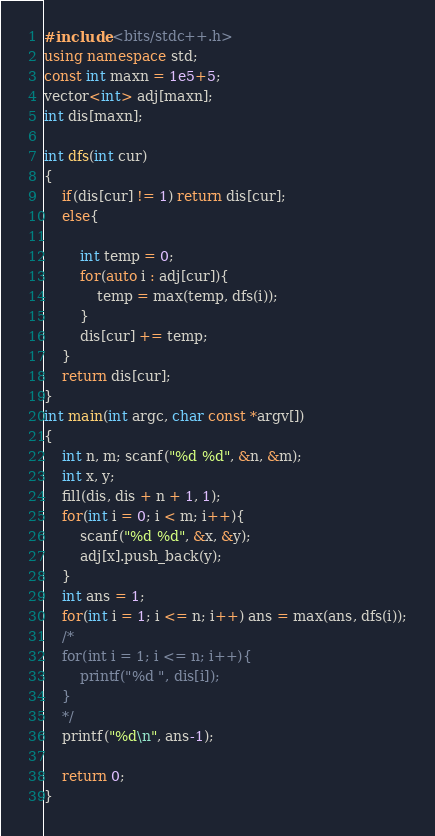<code> <loc_0><loc_0><loc_500><loc_500><_C++_>#include <bits/stdc++.h>
using namespace std;
const int maxn = 1e5+5;
vector<int> adj[maxn];
int dis[maxn];

int dfs(int cur)
{
	if(dis[cur] != 1) return dis[cur];
	else{

		int temp = 0;
		for(auto i : adj[cur]){
			temp = max(temp, dfs(i));
		}
		dis[cur] += temp;
	}
	return dis[cur];
}
int main(int argc, char const *argv[])
{
	int n, m; scanf("%d %d", &n, &m);
	int x, y;
	fill(dis, dis + n + 1, 1);
	for(int i = 0; i < m; i++){
		scanf("%d %d", &x, &y);
		adj[x].push_back(y);
	}
	int ans = 1;
	for(int i = 1; i <= n; i++) ans = max(ans, dfs(i));
	/*	
	for(int i = 1; i <= n; i++){
		printf("%d ", dis[i]);
	}
	*/
	printf("%d\n", ans-1);

	return 0;
}</code> 